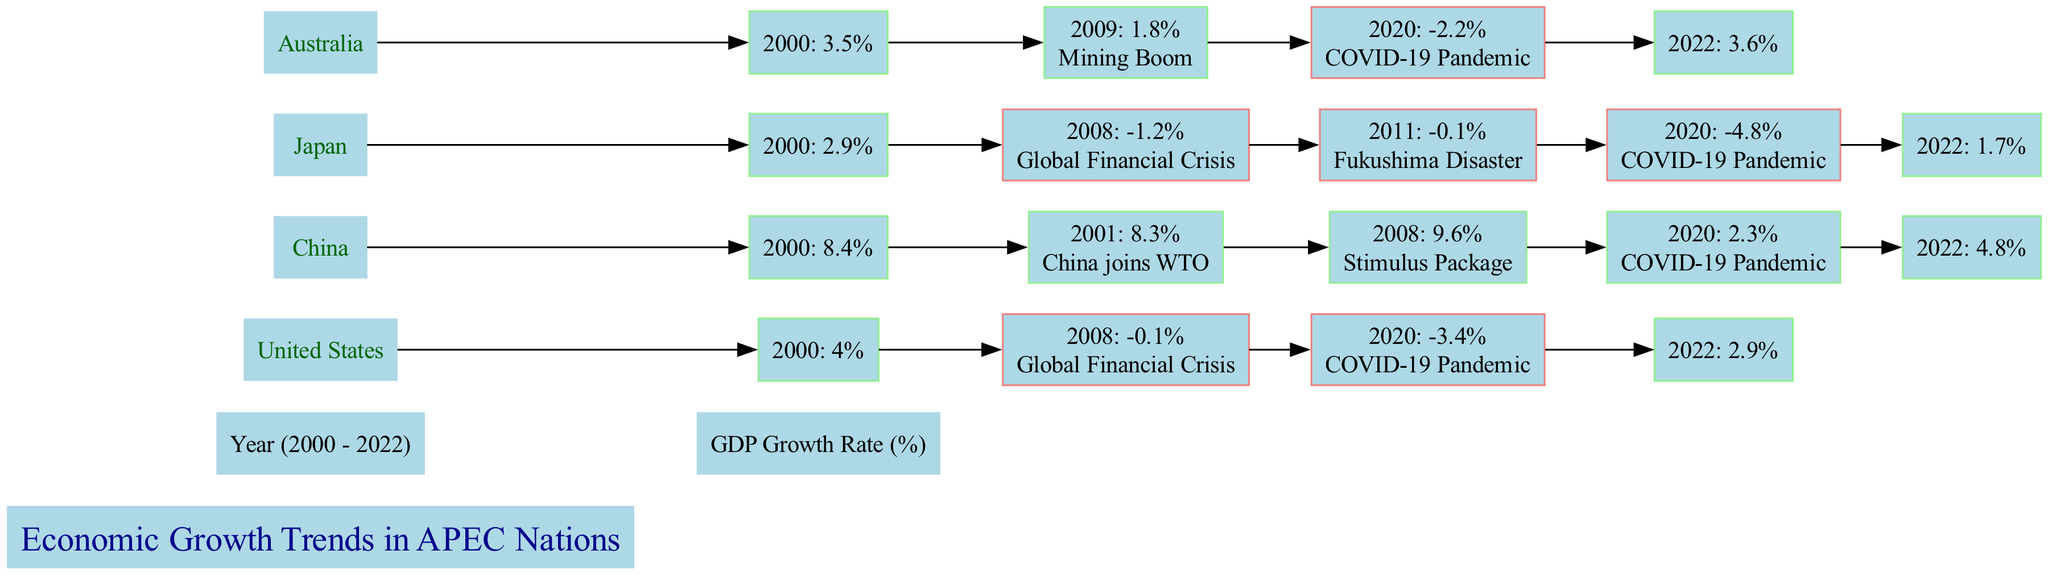What was the GDP growth rate of the United States in 2008? The diagram shows that in 2008, the GDP growth rate for the United States was -0.1%. This information can be found directly in the bar corresponding to the year 2008 for the United States.
Answer: -0.1% Which country had the highest GDP growth rate in 2022? The bar for China in 2022 indicates a GDP growth rate of 4.8%, which is higher than all other APEC countries in that year. To arrive at this answer, one needs to compare the 2022 growth rates for each listed country.
Answer: China In which year did Japan experience the lowest GDP growth rate? By examining the years listed for Japan, the year 2020 shows a GDP growth rate of -4.8%, which is the lowest among the recorded years for Japan. This conclusion can be reached by comparing all the growth rates for Japan.
Answer: 2020 What key event influenced China's GDP growth in 2001? The annotation for the year 2001 under China's bar indicates that China joined the WTO, which is a significant event impacting its economic growth. This can be found by checking the annotation associated with the 2001 data point for China.
Answer: China joins WTO What was the GDP growth rate of Australia in 2009? The diagram shows that Australia's GDP growth rate in 2009 was 1.8%. This number is directly listed under the Australia label for that year in the bar chart.
Answer: 1.8% How did the Global Financial Crisis impact Japan's GDP growth rate? The diagram shows Japan's GDP growth rate in 2008 was -1.2%, which is a decline from the previous year. This drop can be directly linked to the Global Financial Crisis as annotated for 2008. Therefore, compared to the growth before the crisis, this shows a negative impact.
Answer: -1.2% What was Australia's GDP growth rate in 2022? The diagram indicates that Australia's GDP growth rate in 2022 was 3.6%. This data is directly extracted from the bar that corresponds to Australia for the year 2022.
Answer: 3.6% Was the GDP growth rate of China higher or lower than that of the United States in 2022? In 2022, China had a GDP growth rate of 4.8%, while the United States had a growth rate of 2.9%. Comparing the two, it is evident that China's growth rate was higher than that of the United States. This conclusion comes from analyzing both countries’ rates for 2022.
Answer: Higher 